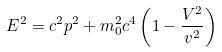Convert formula to latex. <formula><loc_0><loc_0><loc_500><loc_500>E ^ { 2 } = c ^ { 2 } p ^ { 2 } + m _ { 0 } ^ { 2 } c ^ { 4 } \left ( 1 - \frac { V ^ { 2 } } { v ^ { 2 } } \right )</formula> 